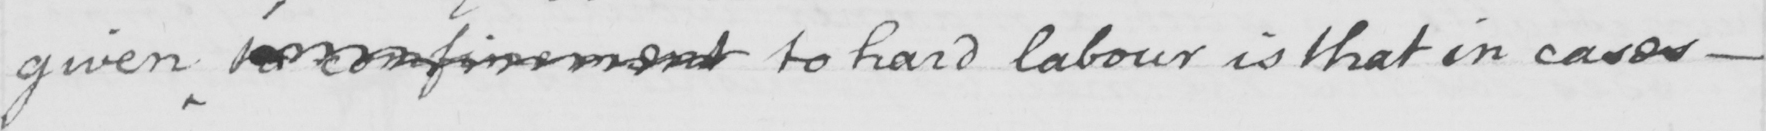Can you read and transcribe this handwriting? given to confinement to hard labour is that in cases _ 